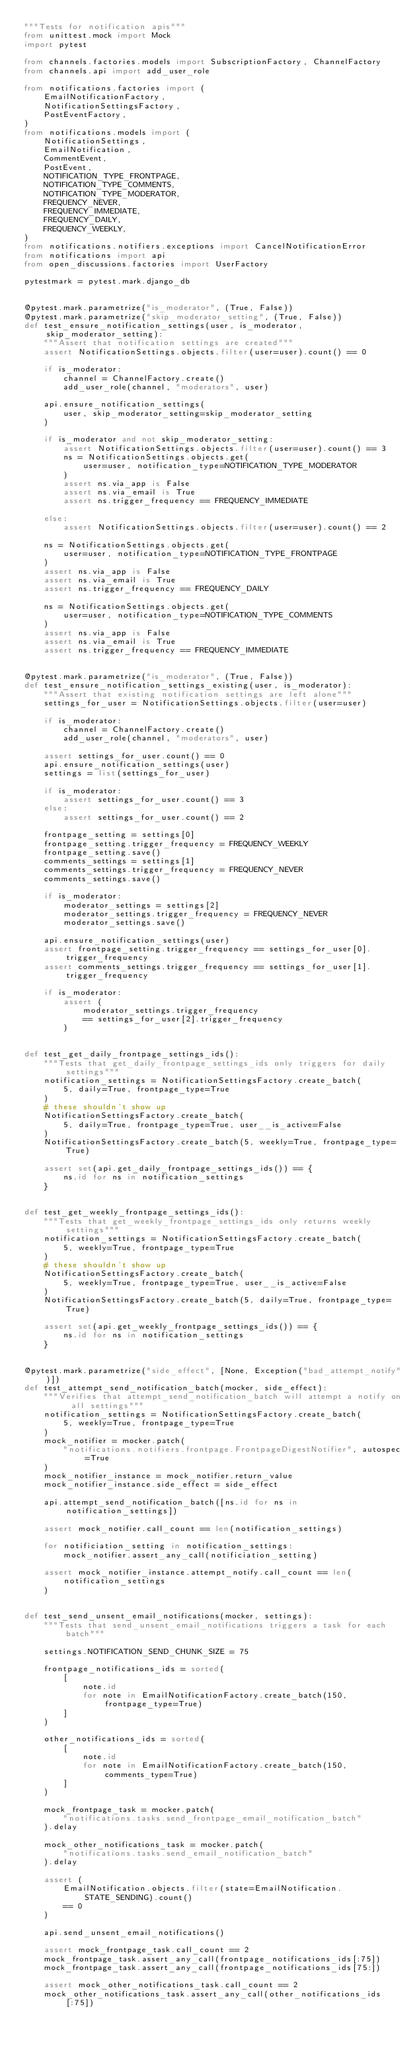<code> <loc_0><loc_0><loc_500><loc_500><_Python_>"""Tests for notification apis"""
from unittest.mock import Mock
import pytest

from channels.factories.models import SubscriptionFactory, ChannelFactory
from channels.api import add_user_role

from notifications.factories import (
    EmailNotificationFactory,
    NotificationSettingsFactory,
    PostEventFactory,
)
from notifications.models import (
    NotificationSettings,
    EmailNotification,
    CommentEvent,
    PostEvent,
    NOTIFICATION_TYPE_FRONTPAGE,
    NOTIFICATION_TYPE_COMMENTS,
    NOTIFICATION_TYPE_MODERATOR,
    FREQUENCY_NEVER,
    FREQUENCY_IMMEDIATE,
    FREQUENCY_DAILY,
    FREQUENCY_WEEKLY,
)
from notifications.notifiers.exceptions import CancelNotificationError
from notifications import api
from open_discussions.factories import UserFactory

pytestmark = pytest.mark.django_db


@pytest.mark.parametrize("is_moderator", (True, False))
@pytest.mark.parametrize("skip_moderator_setting", (True, False))
def test_ensure_notification_settings(user, is_moderator, skip_moderator_setting):
    """Assert that notification settings are created"""
    assert NotificationSettings.objects.filter(user=user).count() == 0

    if is_moderator:
        channel = ChannelFactory.create()
        add_user_role(channel, "moderators", user)

    api.ensure_notification_settings(
        user, skip_moderator_setting=skip_moderator_setting
    )

    if is_moderator and not skip_moderator_setting:
        assert NotificationSettings.objects.filter(user=user).count() == 3
        ns = NotificationSettings.objects.get(
            user=user, notification_type=NOTIFICATION_TYPE_MODERATOR
        )
        assert ns.via_app is False
        assert ns.via_email is True
        assert ns.trigger_frequency == FREQUENCY_IMMEDIATE

    else:
        assert NotificationSettings.objects.filter(user=user).count() == 2

    ns = NotificationSettings.objects.get(
        user=user, notification_type=NOTIFICATION_TYPE_FRONTPAGE
    )
    assert ns.via_app is False
    assert ns.via_email is True
    assert ns.trigger_frequency == FREQUENCY_DAILY

    ns = NotificationSettings.objects.get(
        user=user, notification_type=NOTIFICATION_TYPE_COMMENTS
    )
    assert ns.via_app is False
    assert ns.via_email is True
    assert ns.trigger_frequency == FREQUENCY_IMMEDIATE


@pytest.mark.parametrize("is_moderator", (True, False))
def test_ensure_notification_settings_existing(user, is_moderator):
    """Assert that existing notification settings are left alone"""
    settings_for_user = NotificationSettings.objects.filter(user=user)

    if is_moderator:
        channel = ChannelFactory.create()
        add_user_role(channel, "moderators", user)

    assert settings_for_user.count() == 0
    api.ensure_notification_settings(user)
    settings = list(settings_for_user)

    if is_moderator:
        assert settings_for_user.count() == 3
    else:
        assert settings_for_user.count() == 2

    frontpage_setting = settings[0]
    frontpage_setting.trigger_frequency = FREQUENCY_WEEKLY
    frontpage_setting.save()
    comments_settings = settings[1]
    comments_settings.trigger_frequency = FREQUENCY_NEVER
    comments_settings.save()

    if is_moderator:
        moderator_settings = settings[2]
        moderator_settings.trigger_frequency = FREQUENCY_NEVER
        moderator_settings.save()

    api.ensure_notification_settings(user)
    assert frontpage_setting.trigger_frequency == settings_for_user[0].trigger_frequency
    assert comments_settings.trigger_frequency == settings_for_user[1].trigger_frequency

    if is_moderator:
        assert (
            moderator_settings.trigger_frequency
            == settings_for_user[2].trigger_frequency
        )


def test_get_daily_frontpage_settings_ids():
    """Tests that get_daily_frontpage_settings_ids only triggers for daily settings"""
    notification_settings = NotificationSettingsFactory.create_batch(
        5, daily=True, frontpage_type=True
    )
    # these shouldn't show up
    NotificationSettingsFactory.create_batch(
        5, daily=True, frontpage_type=True, user__is_active=False
    )
    NotificationSettingsFactory.create_batch(5, weekly=True, frontpage_type=True)

    assert set(api.get_daily_frontpage_settings_ids()) == {
        ns.id for ns in notification_settings
    }


def test_get_weekly_frontpage_settings_ids():
    """Tests that get_weekly_frontpage_settings_ids only returns weekly settings"""
    notification_settings = NotificationSettingsFactory.create_batch(
        5, weekly=True, frontpage_type=True
    )
    # these shouldn't show up
    NotificationSettingsFactory.create_batch(
        5, weekly=True, frontpage_type=True, user__is_active=False
    )
    NotificationSettingsFactory.create_batch(5, daily=True, frontpage_type=True)

    assert set(api.get_weekly_frontpage_settings_ids()) == {
        ns.id for ns in notification_settings
    }


@pytest.mark.parametrize("side_effect", [None, Exception("bad_attempt_notify")])
def test_attempt_send_notification_batch(mocker, side_effect):
    """Verifies that attempt_send_notification_batch will attempt a notify on all settings"""
    notification_settings = NotificationSettingsFactory.create_batch(
        5, weekly=True, frontpage_type=True
    )
    mock_notifier = mocker.patch(
        "notifications.notifiers.frontpage.FrontpageDigestNotifier", autospec=True
    )
    mock_notifier_instance = mock_notifier.return_value
    mock_notifier_instance.side_effect = side_effect

    api.attempt_send_notification_batch([ns.id for ns in notification_settings])

    assert mock_notifier.call_count == len(notification_settings)

    for notificiation_setting in notification_settings:
        mock_notifier.assert_any_call(notificiation_setting)

    assert mock_notifier_instance.attempt_notify.call_count == len(
        notification_settings
    )


def test_send_unsent_email_notifications(mocker, settings):
    """Tests that send_unsent_email_notifications triggers a task for each batch"""

    settings.NOTIFICATION_SEND_CHUNK_SIZE = 75

    frontpage_notifications_ids = sorted(
        [
            note.id
            for note in EmailNotificationFactory.create_batch(150, frontpage_type=True)
        ]
    )

    other_notifications_ids = sorted(
        [
            note.id
            for note in EmailNotificationFactory.create_batch(150, comments_type=True)
        ]
    )

    mock_frontpage_task = mocker.patch(
        "notifications.tasks.send_frontpage_email_notification_batch"
    ).delay

    mock_other_notifications_task = mocker.patch(
        "notifications.tasks.send_email_notification_batch"
    ).delay

    assert (
        EmailNotification.objects.filter(state=EmailNotification.STATE_SENDING).count()
        == 0
    )

    api.send_unsent_email_notifications()

    assert mock_frontpage_task.call_count == 2
    mock_frontpage_task.assert_any_call(frontpage_notifications_ids[:75])
    mock_frontpage_task.assert_any_call(frontpage_notifications_ids[75:])

    assert mock_other_notifications_task.call_count == 2
    mock_other_notifications_task.assert_any_call(other_notifications_ids[:75])</code> 